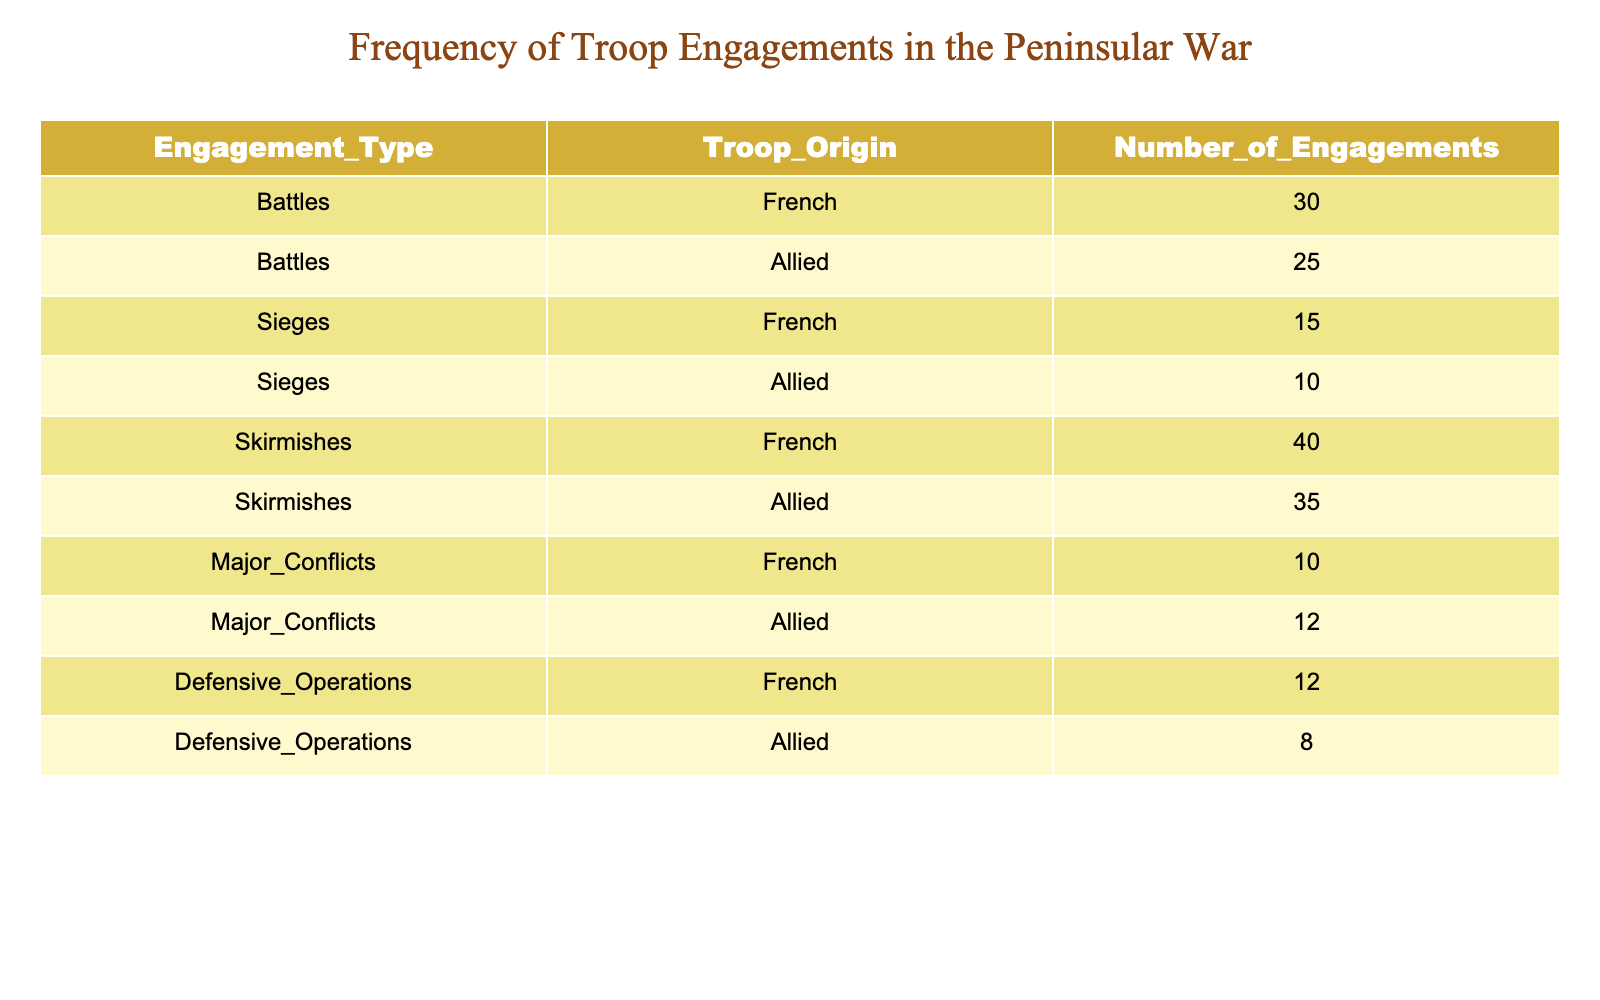What is the total number of engagements for French troops? To find the total for French troops, I need to sum the number of engagements across all types. The values for French engagements are 30 (Battles) + 15 (Sieges) + 40 (Skirmishes) + 10 (Major Conflicts) + 12 (Defensive Operations) = 107.
Answer: 107 What is the total number of engagements for Allied troops? The total for Allied troops can be calculated by adding the engagements in all categories: 25 (Battles) + 10 (Sieges) + 35 (Skirmishes) + 12 (Major Conflicts) + 8 (Defensive Operations) = 90.
Answer: 90 Which troop type had the highest number of skirmishes? By comparing the values in the Skirmishes row, French troops had 40 engagements while Allied troops had 35 engagements, so the highest is with French troops.
Answer: French troops What is the difference in the number of Defensive Operations between French and Allied troops? I will find the number of Defensive Operations for both sides: French troops had 12 engagements and Allied troops had 8 engagements. The difference is 12 - 8 = 4.
Answer: 4 True or False: The French troops engaged in more Major Conflicts than Allied troops. Checking the Major Conflicts row, we see that French troops engaged 10 times while Allied troops engaged 12 times. Therefore, it is false that French troops had more engagements.
Answer: False What is the average number of engagements per type for French troops? To find the average, sum the engagements for French troops (30 + 15 + 40 + 10 + 12 = 107), which gives 107. There are 5 types of engagements, so the average is 107 / 5 = 21.4.
Answer: 21.4 Which category had the lowest number of total engagements and how many were there? By evaluating the total counts, it appears that the category with the lowest engagements is Major Conflicts: 10 for French and 12 for Allied, so the lowest is French troops with 10.
Answer: 10 What is the combined total of Battles and Sieges for both troop origins? First, calculate the total number of Battles: French (30) + Allied (25) = 55. For Sieges: French (15) + Allied (10) = 25. Summing these gives 55 + 25 = 80.
Answer: 80 